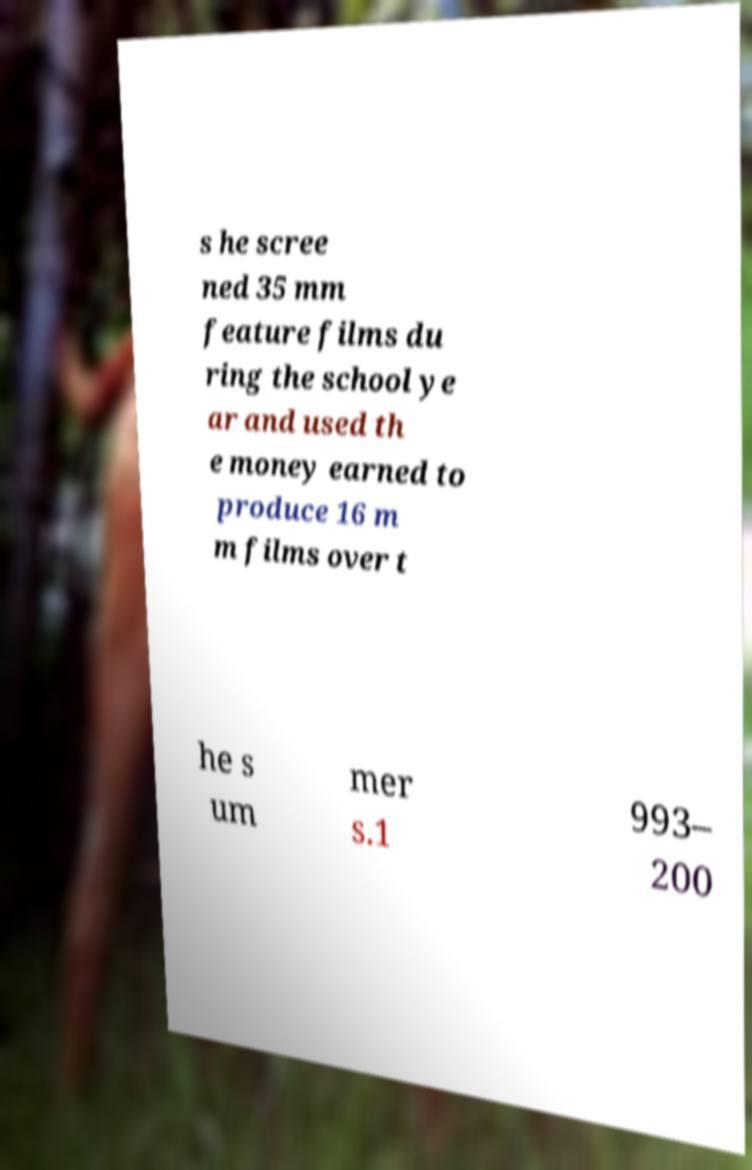Please read and relay the text visible in this image. What does it say? s he scree ned 35 mm feature films du ring the school ye ar and used th e money earned to produce 16 m m films over t he s um mer s.1 993– 200 